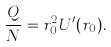<formula> <loc_0><loc_0><loc_500><loc_500>\frac { Q } { N } = r _ { 0 } ^ { 2 } U ^ { \prime } ( r _ { 0 } ) .</formula> 